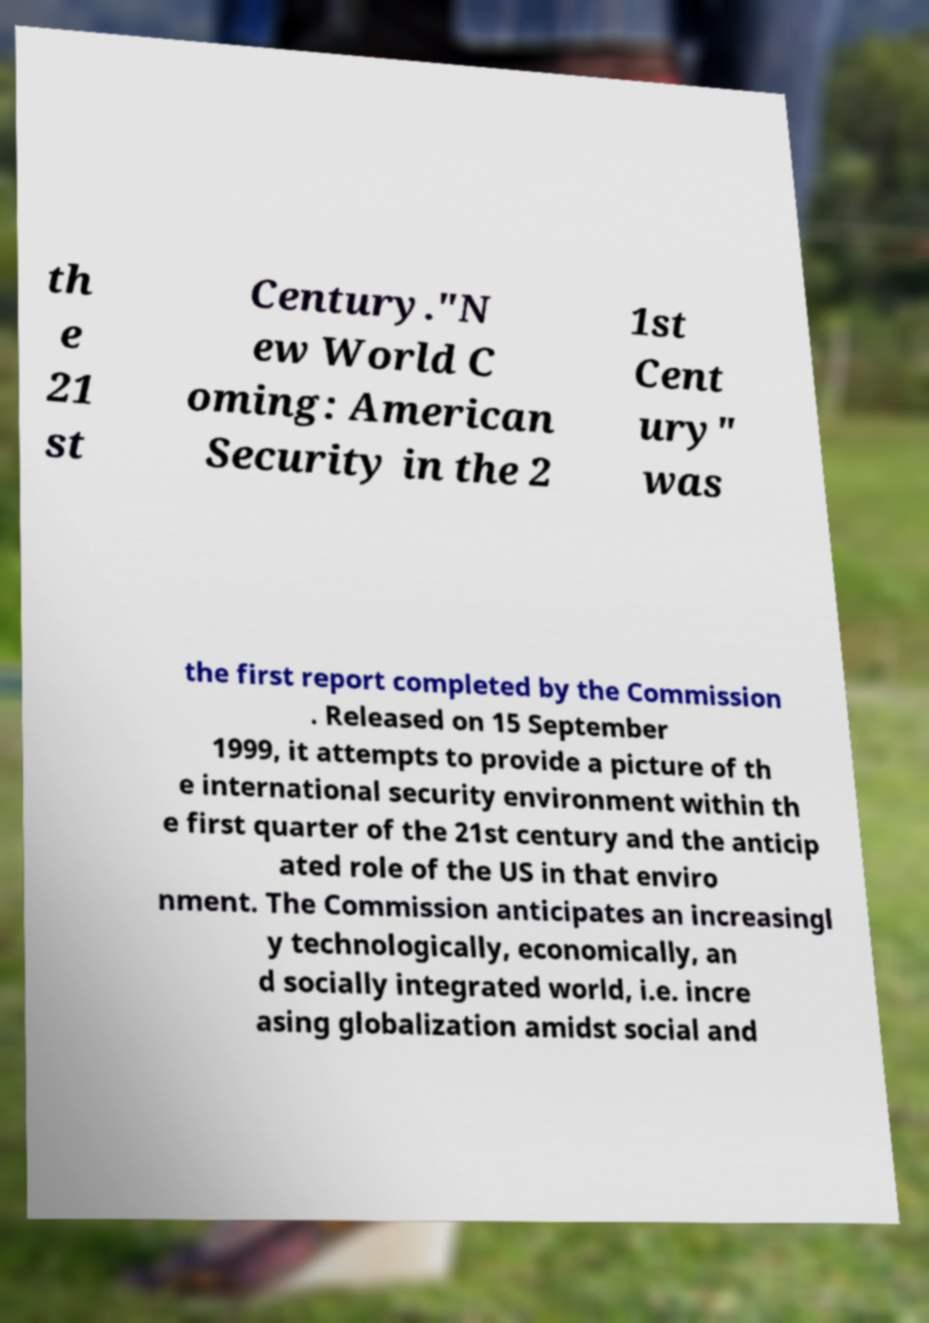Could you extract and type out the text from this image? th e 21 st Century."N ew World C oming: American Security in the 2 1st Cent ury" was the first report completed by the Commission . Released on 15 September 1999, it attempts to provide a picture of th e international security environment within th e first quarter of the 21st century and the anticip ated role of the US in that enviro nment. The Commission anticipates an increasingl y technologically, economically, an d socially integrated world, i.e. incre asing globalization amidst social and 